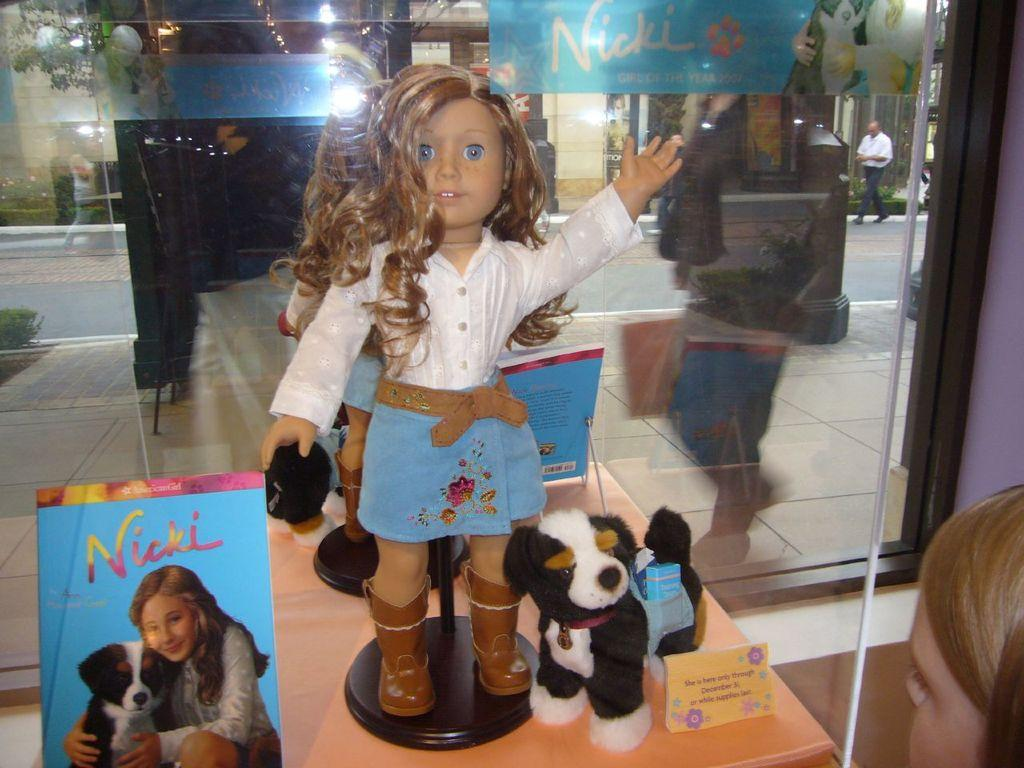What is the main subject of the image? There is a doll in the image. What else can be seen in the image besides the doll? There are toys on a table, a girl on the right side of the image, a road visible in the background, a person walking in the background, and a book on the left side of the image. How many kittens are hiding in the girl's pocket in the image? There are no kittens present in the image, and the girl's pocket is not visible. 